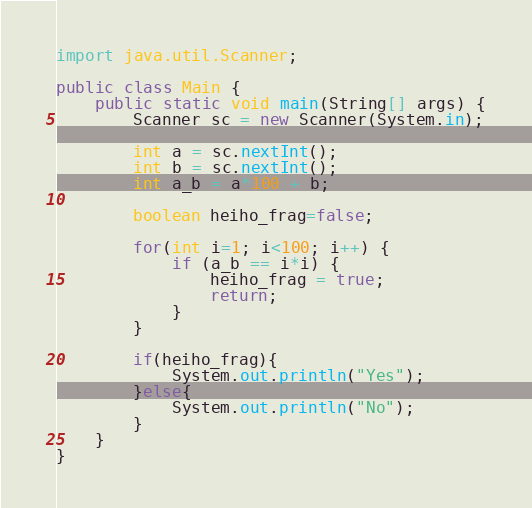<code> <loc_0><loc_0><loc_500><loc_500><_Java_>import java.util.Scanner;

public class Main {
    public static void main(String[] args) {
        Scanner sc = new Scanner(System.in);

        int a = sc.nextInt();
        int b = sc.nextInt();
        int a_b = a*100 + b;

        boolean heiho_frag=false;

        for(int i=1; i<100; i++) {
            if (a_b == i*i) {
                heiho_frag = true;
                return;
            }
        }

        if(heiho_frag){
            System.out.println("Yes");
        }else{
            System.out.println("No");
        }
    }
}</code> 